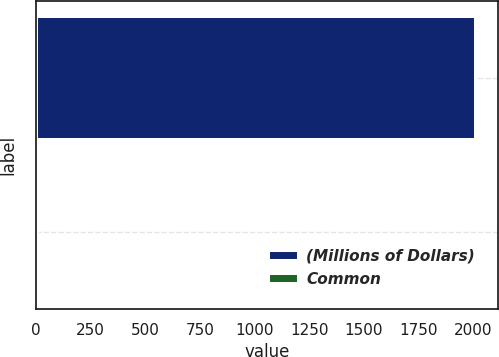<chart> <loc_0><loc_0><loc_500><loc_500><bar_chart><fcel>(Millions of Dollars)<fcel>Common<nl><fcel>2013<fcel>3<nl></chart> 